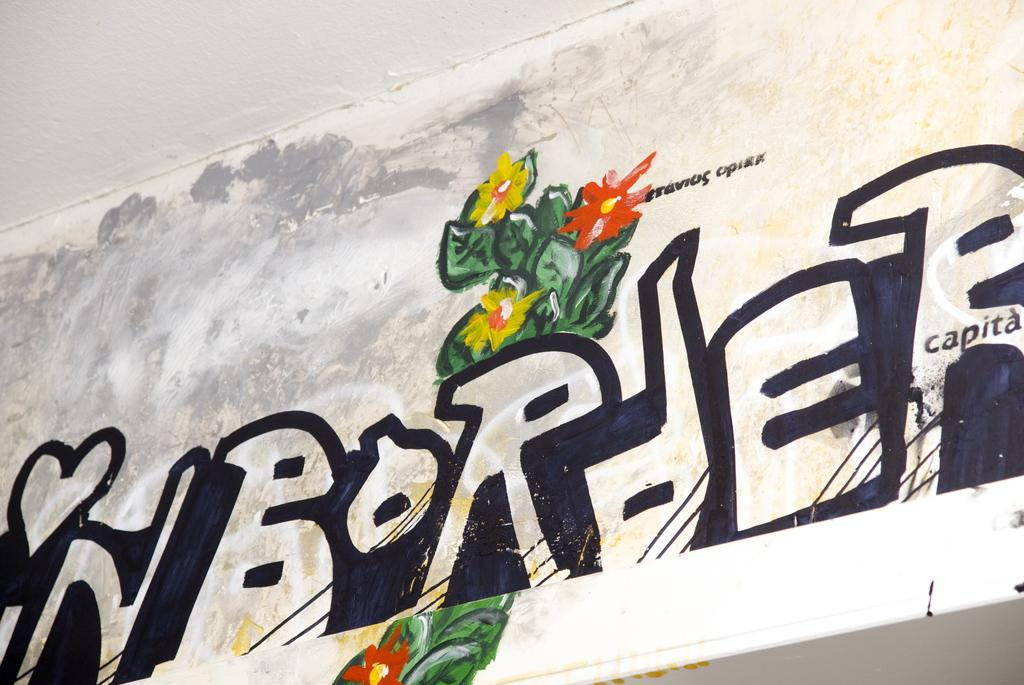What can be seen on the wall in the image? There is text and a painting on the wall in the image. Can you describe the painting on the wall? Unfortunately, the facts provided do not give any details about the painting. What type of surface is the text written on? The text is written on the wall in the image. What type of marble is used for the box in the image? There is no box or marble present in the image. How many cellars can be seen in the image? There are no cellars visible in the image; the image features text and a painting on a wall. 